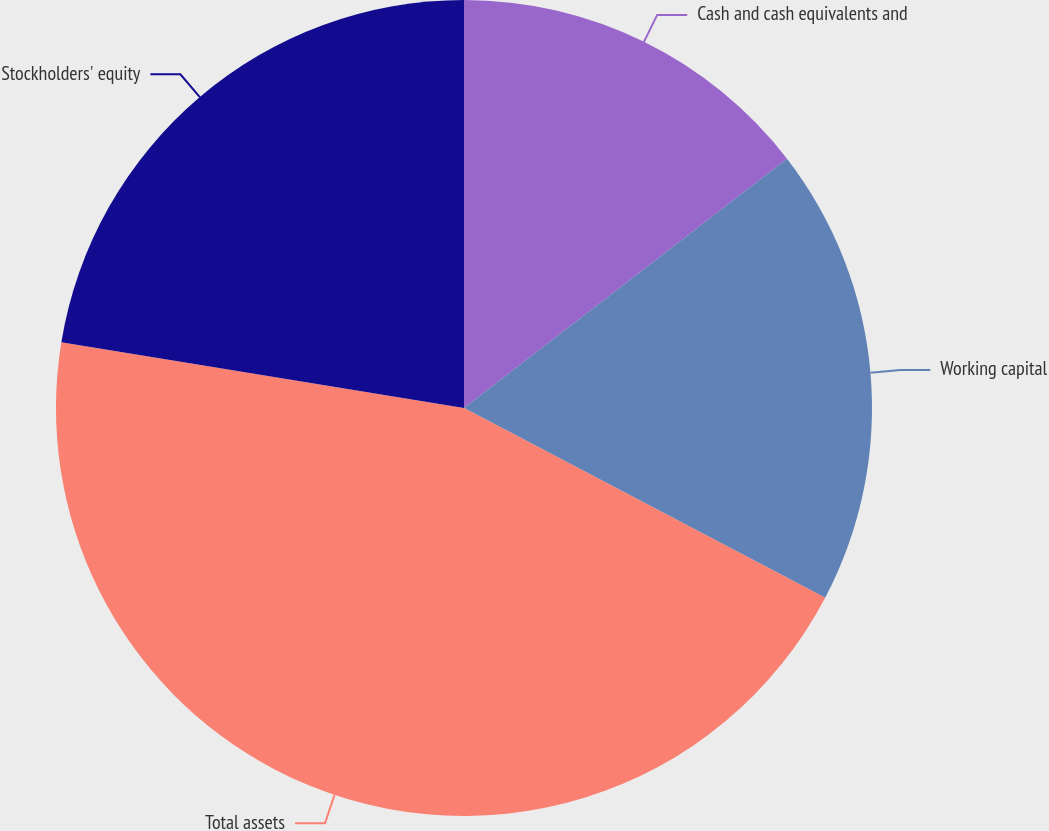Convert chart. <chart><loc_0><loc_0><loc_500><loc_500><pie_chart><fcel>Cash and cash equivalents and<fcel>Working capital<fcel>Total assets<fcel>Stockholders' equity<nl><fcel>14.54%<fcel>18.16%<fcel>44.88%<fcel>22.42%<nl></chart> 